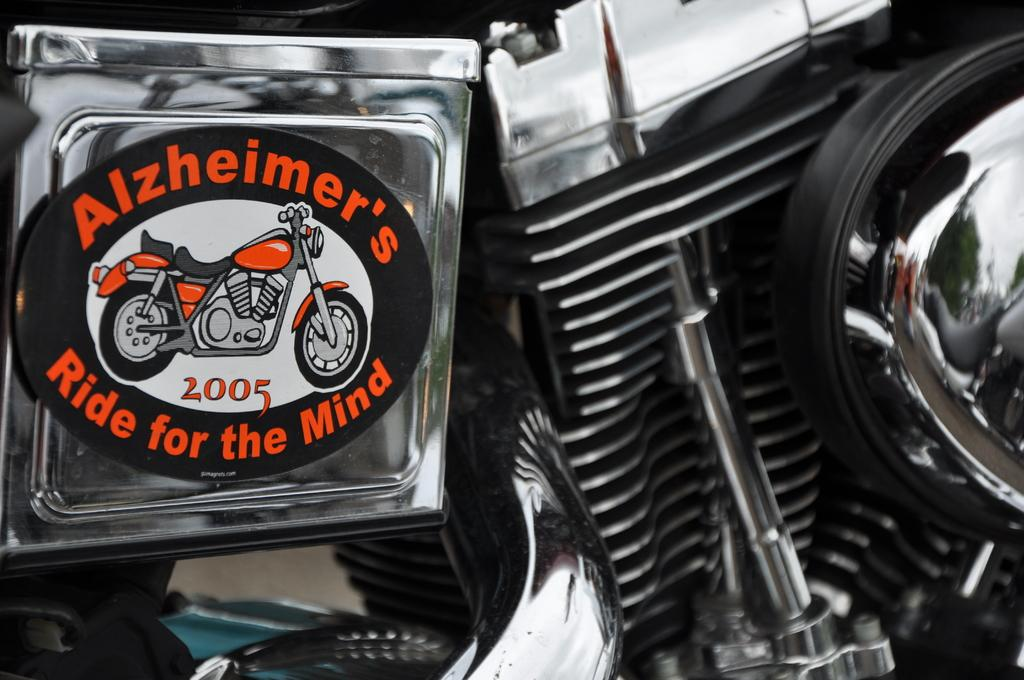What is the main object in the image? There is a bike in the image. Can you describe the bike in the image? The bike appears to be the main focus of the image, but no specific details about its color, style, or condition are provided. Is there anyone riding the bike in the image? The facts provided do not mention anyone riding the bike or any other people in the image. What decision did the bike's brother make in the image? There is no mention of a bike's brother or any decisions being made in the image. 